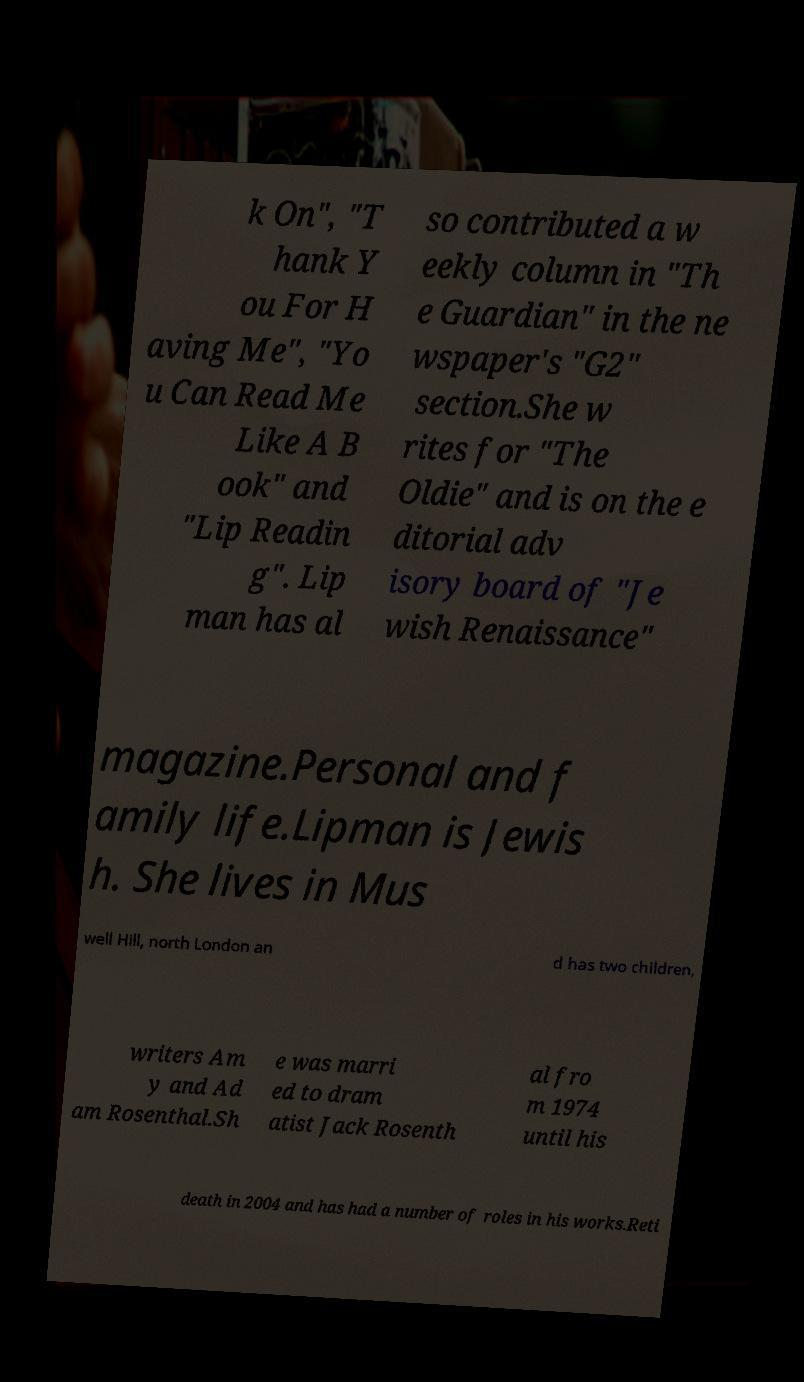What messages or text are displayed in this image? I need them in a readable, typed format. k On", "T hank Y ou For H aving Me", "Yo u Can Read Me Like A B ook" and "Lip Readin g". Lip man has al so contributed a w eekly column in "Th e Guardian" in the ne wspaper's "G2" section.She w rites for "The Oldie" and is on the e ditorial adv isory board of "Je wish Renaissance" magazine.Personal and f amily life.Lipman is Jewis h. She lives in Mus well Hill, north London an d has two children, writers Am y and Ad am Rosenthal.Sh e was marri ed to dram atist Jack Rosenth al fro m 1974 until his death in 2004 and has had a number of roles in his works.Reti 